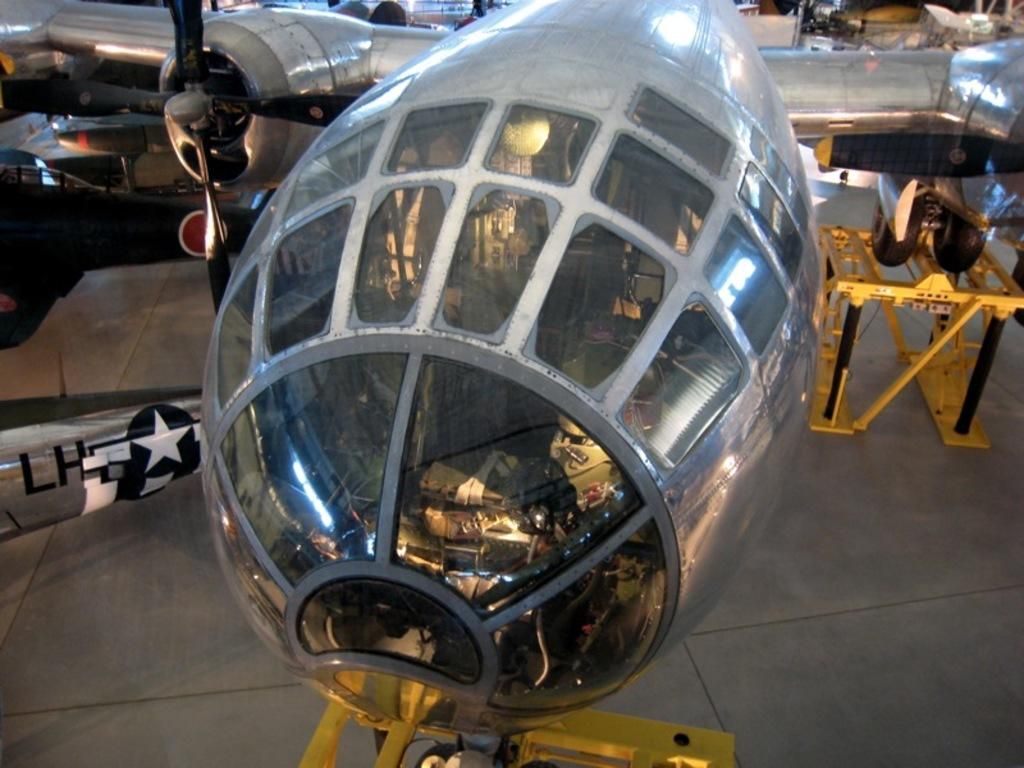What is the main subject of the picture? The main subject of the picture is an air craft. Can you describe the air craft's position in the image? The air craft is on a path in the image. What is the color of the air craft? The air craft is gray in color. Does the air craft have any specific features? Yes, the air craft has windows (glasses). What can be seen under the air craft in the image? There are yellow stands under the air craft. How many chairs are placed inside the air craft in the image? There is no information about chairs inside the air craft in the image, as it only shows the air craft on a path with yellow stands underneath. 